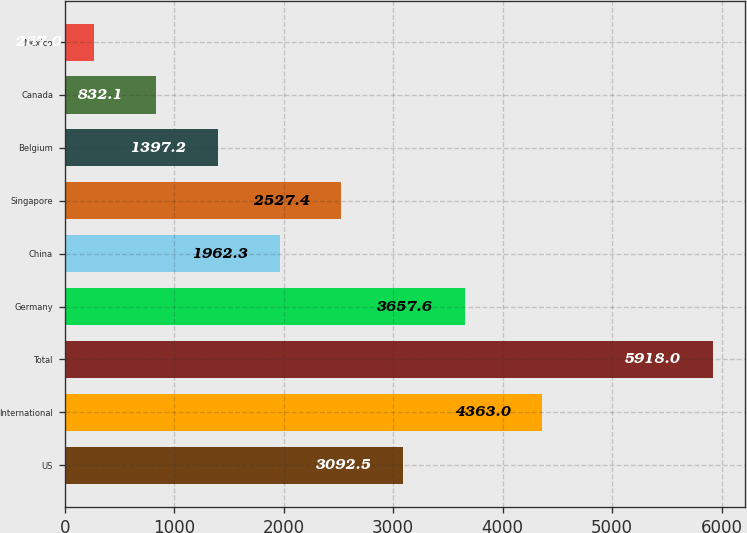Convert chart to OTSL. <chart><loc_0><loc_0><loc_500><loc_500><bar_chart><fcel>US<fcel>International<fcel>Total<fcel>Germany<fcel>China<fcel>Singapore<fcel>Belgium<fcel>Canada<fcel>Mexico<nl><fcel>3092.5<fcel>4363<fcel>5918<fcel>3657.6<fcel>1962.3<fcel>2527.4<fcel>1397.2<fcel>832.1<fcel>267<nl></chart> 